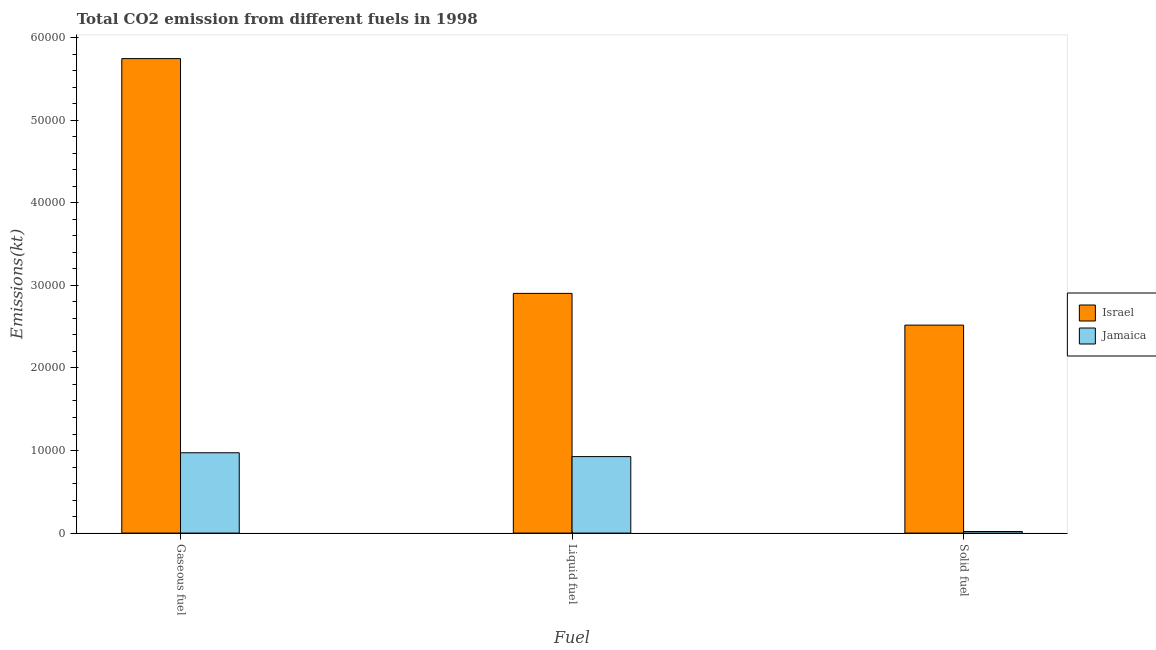How many groups of bars are there?
Your response must be concise. 3. Are the number of bars on each tick of the X-axis equal?
Give a very brief answer. Yes. How many bars are there on the 2nd tick from the left?
Offer a very short reply. 2. How many bars are there on the 1st tick from the right?
Offer a very short reply. 2. What is the label of the 3rd group of bars from the left?
Keep it short and to the point. Solid fuel. What is the amount of co2 emissions from gaseous fuel in Israel?
Offer a terse response. 5.75e+04. Across all countries, what is the maximum amount of co2 emissions from gaseous fuel?
Give a very brief answer. 5.75e+04. Across all countries, what is the minimum amount of co2 emissions from gaseous fuel?
Your answer should be very brief. 9728.55. In which country was the amount of co2 emissions from solid fuel maximum?
Provide a succinct answer. Israel. In which country was the amount of co2 emissions from solid fuel minimum?
Keep it short and to the point. Jamaica. What is the total amount of co2 emissions from solid fuel in the graph?
Provide a succinct answer. 2.54e+04. What is the difference between the amount of co2 emissions from gaseous fuel in Jamaica and that in Israel?
Your response must be concise. -4.77e+04. What is the difference between the amount of co2 emissions from gaseous fuel in Israel and the amount of co2 emissions from solid fuel in Jamaica?
Offer a very short reply. 5.73e+04. What is the average amount of co2 emissions from liquid fuel per country?
Your answer should be compact. 1.91e+04. What is the difference between the amount of co2 emissions from gaseous fuel and amount of co2 emissions from liquid fuel in Jamaica?
Your answer should be very brief. 465.71. In how many countries, is the amount of co2 emissions from gaseous fuel greater than 46000 kt?
Ensure brevity in your answer.  1. What is the ratio of the amount of co2 emissions from liquid fuel in Israel to that in Jamaica?
Provide a succinct answer. 3.13. Is the amount of co2 emissions from solid fuel in Jamaica less than that in Israel?
Your response must be concise. Yes. What is the difference between the highest and the second highest amount of co2 emissions from solid fuel?
Provide a short and direct response. 2.50e+04. What is the difference between the highest and the lowest amount of co2 emissions from gaseous fuel?
Give a very brief answer. 4.77e+04. Is the sum of the amount of co2 emissions from liquid fuel in Jamaica and Israel greater than the maximum amount of co2 emissions from solid fuel across all countries?
Make the answer very short. Yes. Is it the case that in every country, the sum of the amount of co2 emissions from gaseous fuel and amount of co2 emissions from liquid fuel is greater than the amount of co2 emissions from solid fuel?
Your answer should be compact. Yes. How many bars are there?
Provide a succinct answer. 6. Are all the bars in the graph horizontal?
Your response must be concise. No. How many countries are there in the graph?
Offer a terse response. 2. Are the values on the major ticks of Y-axis written in scientific E-notation?
Offer a terse response. No. Does the graph contain any zero values?
Ensure brevity in your answer.  No. Where does the legend appear in the graph?
Your response must be concise. Center right. What is the title of the graph?
Ensure brevity in your answer.  Total CO2 emission from different fuels in 1998. What is the label or title of the X-axis?
Provide a succinct answer. Fuel. What is the label or title of the Y-axis?
Ensure brevity in your answer.  Emissions(kt). What is the Emissions(kt) in Israel in Gaseous fuel?
Your answer should be compact. 5.75e+04. What is the Emissions(kt) in Jamaica in Gaseous fuel?
Provide a short and direct response. 9728.55. What is the Emissions(kt) of Israel in Liquid fuel?
Offer a terse response. 2.90e+04. What is the Emissions(kt) of Jamaica in Liquid fuel?
Your response must be concise. 9262.84. What is the Emissions(kt) in Israel in Solid fuel?
Provide a succinct answer. 2.52e+04. What is the Emissions(kt) of Jamaica in Solid fuel?
Your response must be concise. 187.02. Across all Fuel, what is the maximum Emissions(kt) in Israel?
Give a very brief answer. 5.75e+04. Across all Fuel, what is the maximum Emissions(kt) in Jamaica?
Provide a short and direct response. 9728.55. Across all Fuel, what is the minimum Emissions(kt) in Israel?
Offer a terse response. 2.52e+04. Across all Fuel, what is the minimum Emissions(kt) in Jamaica?
Provide a short and direct response. 187.02. What is the total Emissions(kt) in Israel in the graph?
Offer a terse response. 1.12e+05. What is the total Emissions(kt) of Jamaica in the graph?
Give a very brief answer. 1.92e+04. What is the difference between the Emissions(kt) of Israel in Gaseous fuel and that in Liquid fuel?
Offer a terse response. 2.84e+04. What is the difference between the Emissions(kt) in Jamaica in Gaseous fuel and that in Liquid fuel?
Keep it short and to the point. 465.71. What is the difference between the Emissions(kt) of Israel in Gaseous fuel and that in Solid fuel?
Make the answer very short. 3.23e+04. What is the difference between the Emissions(kt) of Jamaica in Gaseous fuel and that in Solid fuel?
Your answer should be very brief. 9541.53. What is the difference between the Emissions(kt) in Israel in Liquid fuel and that in Solid fuel?
Give a very brief answer. 3843.02. What is the difference between the Emissions(kt) of Jamaica in Liquid fuel and that in Solid fuel?
Your response must be concise. 9075.83. What is the difference between the Emissions(kt) of Israel in Gaseous fuel and the Emissions(kt) of Jamaica in Liquid fuel?
Give a very brief answer. 4.82e+04. What is the difference between the Emissions(kt) in Israel in Gaseous fuel and the Emissions(kt) in Jamaica in Solid fuel?
Give a very brief answer. 5.73e+04. What is the difference between the Emissions(kt) of Israel in Liquid fuel and the Emissions(kt) of Jamaica in Solid fuel?
Give a very brief answer. 2.88e+04. What is the average Emissions(kt) in Israel per Fuel?
Provide a succinct answer. 3.72e+04. What is the average Emissions(kt) in Jamaica per Fuel?
Give a very brief answer. 6392.8. What is the difference between the Emissions(kt) in Israel and Emissions(kt) in Jamaica in Gaseous fuel?
Ensure brevity in your answer.  4.77e+04. What is the difference between the Emissions(kt) in Israel and Emissions(kt) in Jamaica in Liquid fuel?
Give a very brief answer. 1.98e+04. What is the difference between the Emissions(kt) of Israel and Emissions(kt) of Jamaica in Solid fuel?
Give a very brief answer. 2.50e+04. What is the ratio of the Emissions(kt) in Israel in Gaseous fuel to that in Liquid fuel?
Give a very brief answer. 1.98. What is the ratio of the Emissions(kt) of Jamaica in Gaseous fuel to that in Liquid fuel?
Your answer should be very brief. 1.05. What is the ratio of the Emissions(kt) in Israel in Gaseous fuel to that in Solid fuel?
Keep it short and to the point. 2.28. What is the ratio of the Emissions(kt) of Jamaica in Gaseous fuel to that in Solid fuel?
Your answer should be compact. 52.02. What is the ratio of the Emissions(kt) in Israel in Liquid fuel to that in Solid fuel?
Give a very brief answer. 1.15. What is the ratio of the Emissions(kt) in Jamaica in Liquid fuel to that in Solid fuel?
Give a very brief answer. 49.53. What is the difference between the highest and the second highest Emissions(kt) of Israel?
Keep it short and to the point. 2.84e+04. What is the difference between the highest and the second highest Emissions(kt) in Jamaica?
Keep it short and to the point. 465.71. What is the difference between the highest and the lowest Emissions(kt) of Israel?
Your response must be concise. 3.23e+04. What is the difference between the highest and the lowest Emissions(kt) in Jamaica?
Provide a succinct answer. 9541.53. 